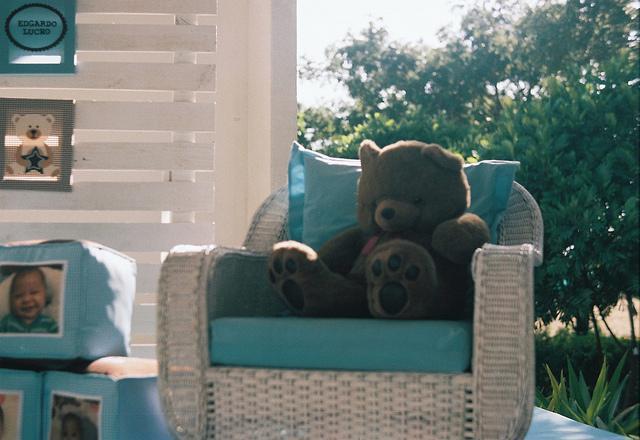How did the bear get there?
Answer the question by selecting the correct answer among the 4 following choices and explain your choice with a short sentence. The answer should be formatted with the following format: `Answer: choice
Rationale: rationale.`
Options: Fell, blew there, climbed up, placed there. Answer: placed there.
Rationale: The teddy bear is sitting on a chair. 